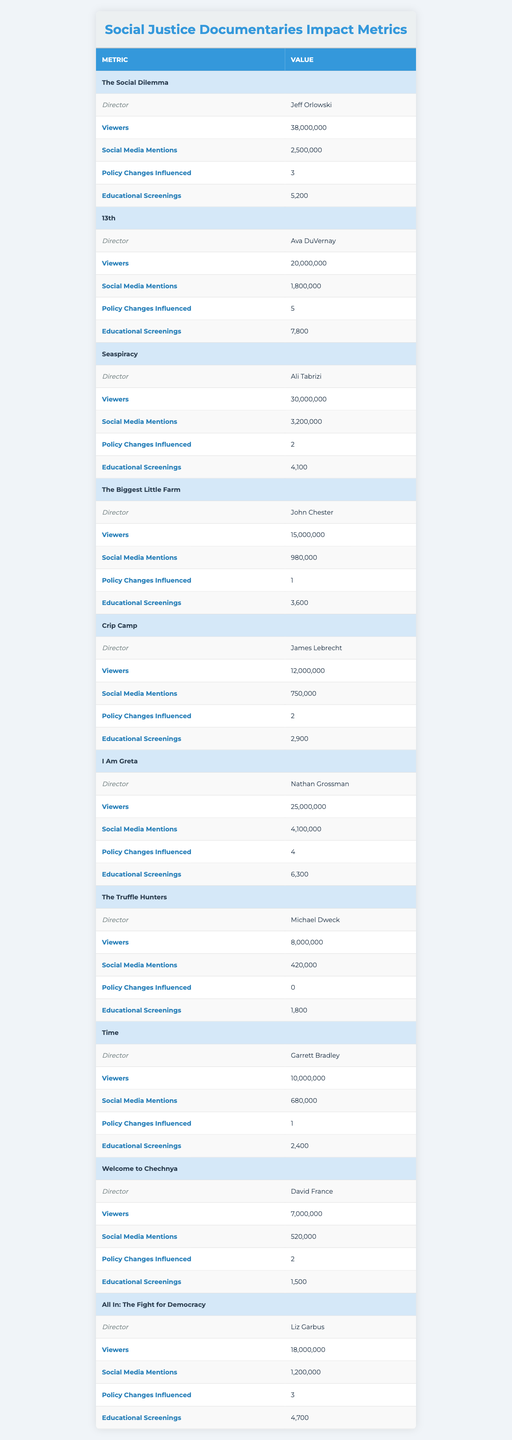What is the title of the documentary directed by Ava DuVernay? The table lists the directors alongside their respective documentaries. By locating Ava DuVernay’s entry, we find that the title is "13th."
Answer: 13th How many viewers did "The Social Dilemma" have? Referring to the row for "The Social Dilemma," it shows that there were 38,000,000 viewers.
Answer: 38,000,000 Which documentary influenced the most policy changes? The table indicates "13th" influenced 5 policy changes, which is the highest number compared to others.
Answer: 13th What is the average number of educational screenings across all documentaries? To find the average, sum the educational screenings (5200 + 7800 + 4100 + 3600 + 2900 + 6300 + 1800 + 2400 + 1500 + 4700 = 29,500) and divide by the number of documentaries (10). Average = 29,500 / 10 = 2950.
Answer: 2950 Did "The Truffle Hunters" have more social media mentions than "Crip Camp"? By comparing the numbers, "The Truffle Hunters" has 420,000 social media mentions and "Crip Camp" has 750,000. Since 420,000 is less than 750,000, the answer is no.
Answer: No How many educational screenings did the documentary with the least viewers have? The documentary with the least viewers is "The Truffle Hunters," which had 1,800 educational screenings.
Answer: 1,800 Which documentary had over 4 million social media mentions? The table shows that "I Am Greta" had 4,100,000 social media mentions, which is over 4 million.
Answer: I Am Greta What is the total number of policy changes influenced by all documentaries? To find the total, add the number of policy changes from each documentary (3 + 5 + 2 + 1 + 2 + 4 + 0 + 1 + 2 + 3 = 23).
Answer: 23 How many documentaries had fewer than 10,000,000 viewers? In the table, the documentaries "The Truffle Hunters," "Time," and "Welcome to Chechnya" have fewer than 10,000,000 viewers, making a total of 3.
Answer: 3 Which director had the highest viewer count for their documentary? By examining the viewer counts for each documentary, "The Social Dilemma," directed by Jeff Orlowski, has the highest count of 38,000,000 viewers.
Answer: Jeff Orlowski 